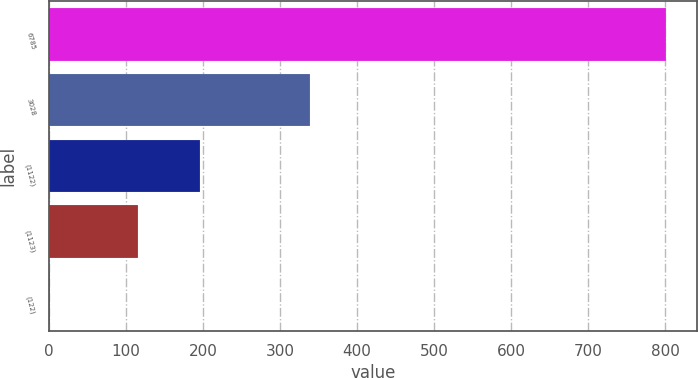Convert chart to OTSL. <chart><loc_0><loc_0><loc_500><loc_500><bar_chart><fcel>6785<fcel>3028<fcel>(1122)<fcel>(1123)<fcel>(122)<nl><fcel>801.6<fcel>338.7<fcel>196.43<fcel>116.4<fcel>1.27<nl></chart> 